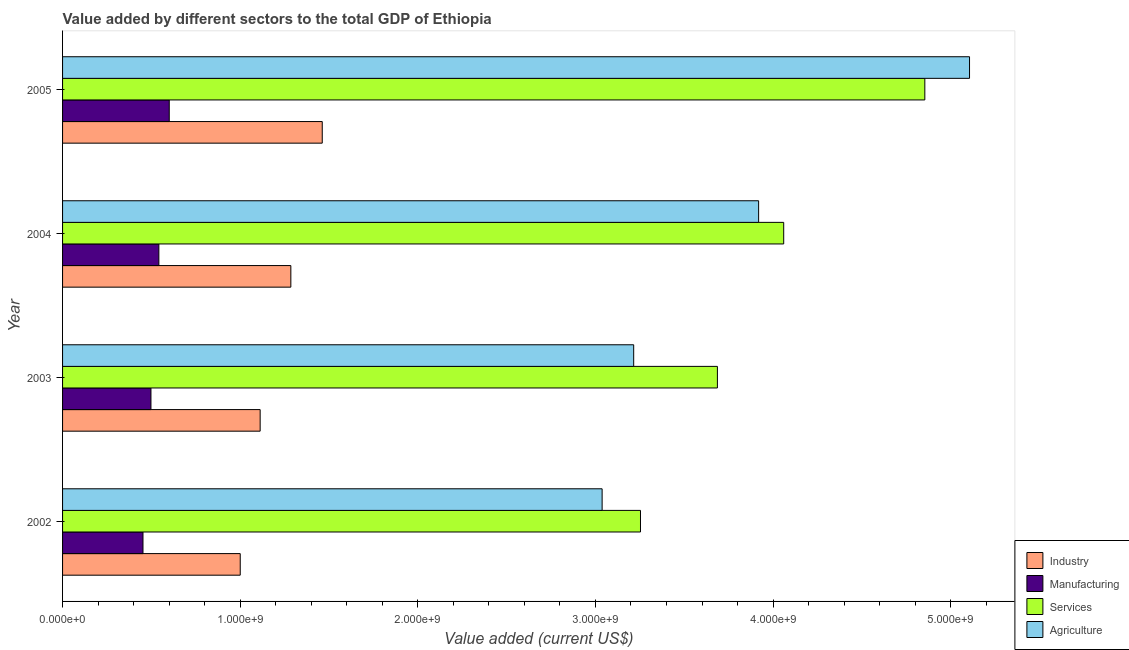Are the number of bars per tick equal to the number of legend labels?
Ensure brevity in your answer.  Yes. Are the number of bars on each tick of the Y-axis equal?
Keep it short and to the point. Yes. How many bars are there on the 4th tick from the bottom?
Ensure brevity in your answer.  4. What is the label of the 1st group of bars from the top?
Your response must be concise. 2005. What is the value added by industrial sector in 2003?
Offer a very short reply. 1.11e+09. Across all years, what is the maximum value added by services sector?
Your answer should be compact. 4.85e+09. Across all years, what is the minimum value added by services sector?
Your answer should be compact. 3.25e+09. In which year was the value added by industrial sector maximum?
Give a very brief answer. 2005. What is the total value added by services sector in the graph?
Offer a very short reply. 1.59e+1. What is the difference between the value added by services sector in 2003 and that in 2005?
Provide a succinct answer. -1.17e+09. What is the difference between the value added by industrial sector in 2004 and the value added by services sector in 2005?
Provide a succinct answer. -3.57e+09. What is the average value added by agricultural sector per year?
Make the answer very short. 3.82e+09. In the year 2002, what is the difference between the value added by agricultural sector and value added by manufacturing sector?
Provide a succinct answer. 2.58e+09. In how many years, is the value added by agricultural sector greater than 3200000000 US$?
Provide a succinct answer. 3. What is the ratio of the value added by agricultural sector in 2002 to that in 2005?
Your answer should be very brief. 0.59. What is the difference between the highest and the second highest value added by manufacturing sector?
Your answer should be compact. 5.85e+07. What is the difference between the highest and the lowest value added by manufacturing sector?
Your answer should be compact. 1.48e+08. What does the 2nd bar from the top in 2004 represents?
Make the answer very short. Services. What does the 2nd bar from the bottom in 2005 represents?
Your answer should be compact. Manufacturing. How many bars are there?
Offer a terse response. 16. How many years are there in the graph?
Your answer should be compact. 4. Does the graph contain any zero values?
Keep it short and to the point. No. Does the graph contain grids?
Offer a terse response. No. What is the title of the graph?
Your answer should be very brief. Value added by different sectors to the total GDP of Ethiopia. Does "Greece" appear as one of the legend labels in the graph?
Offer a terse response. No. What is the label or title of the X-axis?
Provide a succinct answer. Value added (current US$). What is the label or title of the Y-axis?
Give a very brief answer. Year. What is the Value added (current US$) of Industry in 2002?
Keep it short and to the point. 1.00e+09. What is the Value added (current US$) in Manufacturing in 2002?
Provide a succinct answer. 4.53e+08. What is the Value added (current US$) in Services in 2002?
Provide a succinct answer. 3.25e+09. What is the Value added (current US$) of Agriculture in 2002?
Give a very brief answer. 3.04e+09. What is the Value added (current US$) of Industry in 2003?
Provide a short and direct response. 1.11e+09. What is the Value added (current US$) in Manufacturing in 2003?
Offer a terse response. 4.98e+08. What is the Value added (current US$) of Services in 2003?
Your response must be concise. 3.69e+09. What is the Value added (current US$) in Agriculture in 2003?
Offer a terse response. 3.22e+09. What is the Value added (current US$) of Industry in 2004?
Ensure brevity in your answer.  1.29e+09. What is the Value added (current US$) in Manufacturing in 2004?
Make the answer very short. 5.42e+08. What is the Value added (current US$) of Services in 2004?
Your response must be concise. 4.06e+09. What is the Value added (current US$) in Agriculture in 2004?
Give a very brief answer. 3.92e+09. What is the Value added (current US$) of Industry in 2005?
Provide a succinct answer. 1.46e+09. What is the Value added (current US$) of Manufacturing in 2005?
Ensure brevity in your answer.  6.01e+08. What is the Value added (current US$) of Services in 2005?
Offer a terse response. 4.85e+09. What is the Value added (current US$) in Agriculture in 2005?
Your response must be concise. 5.11e+09. Across all years, what is the maximum Value added (current US$) of Industry?
Ensure brevity in your answer.  1.46e+09. Across all years, what is the maximum Value added (current US$) in Manufacturing?
Make the answer very short. 6.01e+08. Across all years, what is the maximum Value added (current US$) in Services?
Offer a very short reply. 4.85e+09. Across all years, what is the maximum Value added (current US$) of Agriculture?
Make the answer very short. 5.11e+09. Across all years, what is the minimum Value added (current US$) in Industry?
Make the answer very short. 1.00e+09. Across all years, what is the minimum Value added (current US$) in Manufacturing?
Ensure brevity in your answer.  4.53e+08. Across all years, what is the minimum Value added (current US$) of Services?
Make the answer very short. 3.25e+09. Across all years, what is the minimum Value added (current US$) in Agriculture?
Your answer should be compact. 3.04e+09. What is the total Value added (current US$) in Industry in the graph?
Provide a short and direct response. 4.86e+09. What is the total Value added (current US$) of Manufacturing in the graph?
Give a very brief answer. 2.09e+09. What is the total Value added (current US$) of Services in the graph?
Provide a succinct answer. 1.59e+1. What is the total Value added (current US$) in Agriculture in the graph?
Make the answer very short. 1.53e+1. What is the difference between the Value added (current US$) in Industry in 2002 and that in 2003?
Provide a short and direct response. -1.12e+08. What is the difference between the Value added (current US$) in Manufacturing in 2002 and that in 2003?
Your response must be concise. -4.49e+07. What is the difference between the Value added (current US$) in Services in 2002 and that in 2003?
Make the answer very short. -4.33e+08. What is the difference between the Value added (current US$) in Agriculture in 2002 and that in 2003?
Make the answer very short. -1.78e+08. What is the difference between the Value added (current US$) in Industry in 2002 and that in 2004?
Offer a terse response. -2.85e+08. What is the difference between the Value added (current US$) in Manufacturing in 2002 and that in 2004?
Your answer should be very brief. -8.94e+07. What is the difference between the Value added (current US$) of Services in 2002 and that in 2004?
Your answer should be compact. -8.06e+08. What is the difference between the Value added (current US$) of Agriculture in 2002 and that in 2004?
Ensure brevity in your answer.  -8.81e+08. What is the difference between the Value added (current US$) of Industry in 2002 and that in 2005?
Ensure brevity in your answer.  -4.62e+08. What is the difference between the Value added (current US$) in Manufacturing in 2002 and that in 2005?
Provide a succinct answer. -1.48e+08. What is the difference between the Value added (current US$) of Services in 2002 and that in 2005?
Provide a short and direct response. -1.60e+09. What is the difference between the Value added (current US$) of Agriculture in 2002 and that in 2005?
Give a very brief answer. -2.07e+09. What is the difference between the Value added (current US$) of Industry in 2003 and that in 2004?
Offer a terse response. -1.73e+08. What is the difference between the Value added (current US$) of Manufacturing in 2003 and that in 2004?
Provide a short and direct response. -4.45e+07. What is the difference between the Value added (current US$) of Services in 2003 and that in 2004?
Your response must be concise. -3.73e+08. What is the difference between the Value added (current US$) in Agriculture in 2003 and that in 2004?
Offer a very short reply. -7.03e+08. What is the difference between the Value added (current US$) of Industry in 2003 and that in 2005?
Your answer should be very brief. -3.50e+08. What is the difference between the Value added (current US$) in Manufacturing in 2003 and that in 2005?
Your answer should be very brief. -1.03e+08. What is the difference between the Value added (current US$) of Services in 2003 and that in 2005?
Provide a short and direct response. -1.17e+09. What is the difference between the Value added (current US$) of Agriculture in 2003 and that in 2005?
Make the answer very short. -1.89e+09. What is the difference between the Value added (current US$) of Industry in 2004 and that in 2005?
Provide a succinct answer. -1.77e+08. What is the difference between the Value added (current US$) in Manufacturing in 2004 and that in 2005?
Make the answer very short. -5.85e+07. What is the difference between the Value added (current US$) of Services in 2004 and that in 2005?
Offer a terse response. -7.94e+08. What is the difference between the Value added (current US$) of Agriculture in 2004 and that in 2005?
Offer a terse response. -1.19e+09. What is the difference between the Value added (current US$) in Industry in 2002 and the Value added (current US$) in Manufacturing in 2003?
Your answer should be compact. 5.03e+08. What is the difference between the Value added (current US$) in Industry in 2002 and the Value added (current US$) in Services in 2003?
Make the answer very short. -2.69e+09. What is the difference between the Value added (current US$) of Industry in 2002 and the Value added (current US$) of Agriculture in 2003?
Give a very brief answer. -2.22e+09. What is the difference between the Value added (current US$) in Manufacturing in 2002 and the Value added (current US$) in Services in 2003?
Ensure brevity in your answer.  -3.23e+09. What is the difference between the Value added (current US$) in Manufacturing in 2002 and the Value added (current US$) in Agriculture in 2003?
Keep it short and to the point. -2.76e+09. What is the difference between the Value added (current US$) in Services in 2002 and the Value added (current US$) in Agriculture in 2003?
Provide a short and direct response. 3.83e+07. What is the difference between the Value added (current US$) in Industry in 2002 and the Value added (current US$) in Manufacturing in 2004?
Ensure brevity in your answer.  4.58e+08. What is the difference between the Value added (current US$) in Industry in 2002 and the Value added (current US$) in Services in 2004?
Provide a short and direct response. -3.06e+09. What is the difference between the Value added (current US$) in Industry in 2002 and the Value added (current US$) in Agriculture in 2004?
Keep it short and to the point. -2.92e+09. What is the difference between the Value added (current US$) in Manufacturing in 2002 and the Value added (current US$) in Services in 2004?
Keep it short and to the point. -3.61e+09. What is the difference between the Value added (current US$) of Manufacturing in 2002 and the Value added (current US$) of Agriculture in 2004?
Offer a terse response. -3.47e+09. What is the difference between the Value added (current US$) of Services in 2002 and the Value added (current US$) of Agriculture in 2004?
Make the answer very short. -6.65e+08. What is the difference between the Value added (current US$) in Industry in 2002 and the Value added (current US$) in Manufacturing in 2005?
Your answer should be compact. 4.00e+08. What is the difference between the Value added (current US$) of Industry in 2002 and the Value added (current US$) of Services in 2005?
Your response must be concise. -3.85e+09. What is the difference between the Value added (current US$) in Industry in 2002 and the Value added (current US$) in Agriculture in 2005?
Offer a very short reply. -4.11e+09. What is the difference between the Value added (current US$) in Manufacturing in 2002 and the Value added (current US$) in Services in 2005?
Offer a terse response. -4.40e+09. What is the difference between the Value added (current US$) in Manufacturing in 2002 and the Value added (current US$) in Agriculture in 2005?
Offer a very short reply. -4.65e+09. What is the difference between the Value added (current US$) of Services in 2002 and the Value added (current US$) of Agriculture in 2005?
Offer a very short reply. -1.85e+09. What is the difference between the Value added (current US$) of Industry in 2003 and the Value added (current US$) of Manufacturing in 2004?
Offer a very short reply. 5.70e+08. What is the difference between the Value added (current US$) of Industry in 2003 and the Value added (current US$) of Services in 2004?
Your answer should be compact. -2.95e+09. What is the difference between the Value added (current US$) in Industry in 2003 and the Value added (current US$) in Agriculture in 2004?
Provide a succinct answer. -2.81e+09. What is the difference between the Value added (current US$) in Manufacturing in 2003 and the Value added (current US$) in Services in 2004?
Your response must be concise. -3.56e+09. What is the difference between the Value added (current US$) of Manufacturing in 2003 and the Value added (current US$) of Agriculture in 2004?
Keep it short and to the point. -3.42e+09. What is the difference between the Value added (current US$) of Services in 2003 and the Value added (current US$) of Agriculture in 2004?
Keep it short and to the point. -2.32e+08. What is the difference between the Value added (current US$) in Industry in 2003 and the Value added (current US$) in Manufacturing in 2005?
Offer a very short reply. 5.12e+08. What is the difference between the Value added (current US$) of Industry in 2003 and the Value added (current US$) of Services in 2005?
Offer a very short reply. -3.74e+09. What is the difference between the Value added (current US$) of Industry in 2003 and the Value added (current US$) of Agriculture in 2005?
Your answer should be very brief. -3.99e+09. What is the difference between the Value added (current US$) of Manufacturing in 2003 and the Value added (current US$) of Services in 2005?
Provide a succinct answer. -4.36e+09. What is the difference between the Value added (current US$) in Manufacturing in 2003 and the Value added (current US$) in Agriculture in 2005?
Your answer should be very brief. -4.61e+09. What is the difference between the Value added (current US$) in Services in 2003 and the Value added (current US$) in Agriculture in 2005?
Make the answer very short. -1.42e+09. What is the difference between the Value added (current US$) in Industry in 2004 and the Value added (current US$) in Manufacturing in 2005?
Ensure brevity in your answer.  6.85e+08. What is the difference between the Value added (current US$) in Industry in 2004 and the Value added (current US$) in Services in 2005?
Your answer should be very brief. -3.57e+09. What is the difference between the Value added (current US$) of Industry in 2004 and the Value added (current US$) of Agriculture in 2005?
Provide a short and direct response. -3.82e+09. What is the difference between the Value added (current US$) in Manufacturing in 2004 and the Value added (current US$) in Services in 2005?
Give a very brief answer. -4.31e+09. What is the difference between the Value added (current US$) of Manufacturing in 2004 and the Value added (current US$) of Agriculture in 2005?
Your response must be concise. -4.56e+09. What is the difference between the Value added (current US$) in Services in 2004 and the Value added (current US$) in Agriculture in 2005?
Offer a terse response. -1.05e+09. What is the average Value added (current US$) of Industry per year?
Your answer should be very brief. 1.21e+09. What is the average Value added (current US$) of Manufacturing per year?
Give a very brief answer. 5.23e+08. What is the average Value added (current US$) of Services per year?
Offer a terse response. 3.96e+09. What is the average Value added (current US$) of Agriculture per year?
Ensure brevity in your answer.  3.82e+09. In the year 2002, what is the difference between the Value added (current US$) of Industry and Value added (current US$) of Manufacturing?
Your response must be concise. 5.47e+08. In the year 2002, what is the difference between the Value added (current US$) in Industry and Value added (current US$) in Services?
Keep it short and to the point. -2.25e+09. In the year 2002, what is the difference between the Value added (current US$) of Industry and Value added (current US$) of Agriculture?
Keep it short and to the point. -2.04e+09. In the year 2002, what is the difference between the Value added (current US$) of Manufacturing and Value added (current US$) of Services?
Ensure brevity in your answer.  -2.80e+09. In the year 2002, what is the difference between the Value added (current US$) of Manufacturing and Value added (current US$) of Agriculture?
Provide a short and direct response. -2.58e+09. In the year 2002, what is the difference between the Value added (current US$) in Services and Value added (current US$) in Agriculture?
Give a very brief answer. 2.16e+08. In the year 2003, what is the difference between the Value added (current US$) in Industry and Value added (current US$) in Manufacturing?
Your answer should be very brief. 6.15e+08. In the year 2003, what is the difference between the Value added (current US$) in Industry and Value added (current US$) in Services?
Offer a terse response. -2.57e+09. In the year 2003, what is the difference between the Value added (current US$) in Industry and Value added (current US$) in Agriculture?
Your response must be concise. -2.10e+09. In the year 2003, what is the difference between the Value added (current US$) of Manufacturing and Value added (current US$) of Services?
Your answer should be very brief. -3.19e+09. In the year 2003, what is the difference between the Value added (current US$) in Manufacturing and Value added (current US$) in Agriculture?
Your response must be concise. -2.72e+09. In the year 2003, what is the difference between the Value added (current US$) in Services and Value added (current US$) in Agriculture?
Provide a short and direct response. 4.71e+08. In the year 2004, what is the difference between the Value added (current US$) in Industry and Value added (current US$) in Manufacturing?
Give a very brief answer. 7.43e+08. In the year 2004, what is the difference between the Value added (current US$) in Industry and Value added (current US$) in Services?
Your response must be concise. -2.77e+09. In the year 2004, what is the difference between the Value added (current US$) in Industry and Value added (current US$) in Agriculture?
Provide a short and direct response. -2.63e+09. In the year 2004, what is the difference between the Value added (current US$) of Manufacturing and Value added (current US$) of Services?
Offer a terse response. -3.52e+09. In the year 2004, what is the difference between the Value added (current US$) of Manufacturing and Value added (current US$) of Agriculture?
Offer a very short reply. -3.38e+09. In the year 2004, what is the difference between the Value added (current US$) of Services and Value added (current US$) of Agriculture?
Offer a terse response. 1.41e+08. In the year 2005, what is the difference between the Value added (current US$) in Industry and Value added (current US$) in Manufacturing?
Make the answer very short. 8.61e+08. In the year 2005, what is the difference between the Value added (current US$) of Industry and Value added (current US$) of Services?
Keep it short and to the point. -3.39e+09. In the year 2005, what is the difference between the Value added (current US$) of Industry and Value added (current US$) of Agriculture?
Provide a succinct answer. -3.64e+09. In the year 2005, what is the difference between the Value added (current US$) of Manufacturing and Value added (current US$) of Services?
Your response must be concise. -4.25e+09. In the year 2005, what is the difference between the Value added (current US$) in Manufacturing and Value added (current US$) in Agriculture?
Your answer should be very brief. -4.51e+09. In the year 2005, what is the difference between the Value added (current US$) of Services and Value added (current US$) of Agriculture?
Your answer should be very brief. -2.52e+08. What is the ratio of the Value added (current US$) in Industry in 2002 to that in 2003?
Your answer should be compact. 0.9. What is the ratio of the Value added (current US$) in Manufacturing in 2002 to that in 2003?
Keep it short and to the point. 0.91. What is the ratio of the Value added (current US$) in Services in 2002 to that in 2003?
Ensure brevity in your answer.  0.88. What is the ratio of the Value added (current US$) of Agriculture in 2002 to that in 2003?
Ensure brevity in your answer.  0.94. What is the ratio of the Value added (current US$) of Industry in 2002 to that in 2004?
Give a very brief answer. 0.78. What is the ratio of the Value added (current US$) of Manufacturing in 2002 to that in 2004?
Your answer should be compact. 0.84. What is the ratio of the Value added (current US$) in Services in 2002 to that in 2004?
Your answer should be very brief. 0.8. What is the ratio of the Value added (current US$) in Agriculture in 2002 to that in 2004?
Give a very brief answer. 0.78. What is the ratio of the Value added (current US$) of Industry in 2002 to that in 2005?
Offer a very short reply. 0.68. What is the ratio of the Value added (current US$) of Manufacturing in 2002 to that in 2005?
Provide a succinct answer. 0.75. What is the ratio of the Value added (current US$) in Services in 2002 to that in 2005?
Provide a short and direct response. 0.67. What is the ratio of the Value added (current US$) of Agriculture in 2002 to that in 2005?
Your answer should be very brief. 0.59. What is the ratio of the Value added (current US$) of Industry in 2003 to that in 2004?
Your response must be concise. 0.87. What is the ratio of the Value added (current US$) in Manufacturing in 2003 to that in 2004?
Make the answer very short. 0.92. What is the ratio of the Value added (current US$) of Services in 2003 to that in 2004?
Offer a terse response. 0.91. What is the ratio of the Value added (current US$) in Agriculture in 2003 to that in 2004?
Make the answer very short. 0.82. What is the ratio of the Value added (current US$) in Industry in 2003 to that in 2005?
Provide a short and direct response. 0.76. What is the ratio of the Value added (current US$) of Manufacturing in 2003 to that in 2005?
Offer a very short reply. 0.83. What is the ratio of the Value added (current US$) in Services in 2003 to that in 2005?
Offer a terse response. 0.76. What is the ratio of the Value added (current US$) in Agriculture in 2003 to that in 2005?
Offer a terse response. 0.63. What is the ratio of the Value added (current US$) in Industry in 2004 to that in 2005?
Ensure brevity in your answer.  0.88. What is the ratio of the Value added (current US$) of Manufacturing in 2004 to that in 2005?
Keep it short and to the point. 0.9. What is the ratio of the Value added (current US$) in Services in 2004 to that in 2005?
Ensure brevity in your answer.  0.84. What is the ratio of the Value added (current US$) in Agriculture in 2004 to that in 2005?
Provide a succinct answer. 0.77. What is the difference between the highest and the second highest Value added (current US$) in Industry?
Your answer should be compact. 1.77e+08. What is the difference between the highest and the second highest Value added (current US$) in Manufacturing?
Keep it short and to the point. 5.85e+07. What is the difference between the highest and the second highest Value added (current US$) in Services?
Your answer should be compact. 7.94e+08. What is the difference between the highest and the second highest Value added (current US$) of Agriculture?
Keep it short and to the point. 1.19e+09. What is the difference between the highest and the lowest Value added (current US$) in Industry?
Your response must be concise. 4.62e+08. What is the difference between the highest and the lowest Value added (current US$) in Manufacturing?
Keep it short and to the point. 1.48e+08. What is the difference between the highest and the lowest Value added (current US$) in Services?
Your response must be concise. 1.60e+09. What is the difference between the highest and the lowest Value added (current US$) of Agriculture?
Provide a short and direct response. 2.07e+09. 